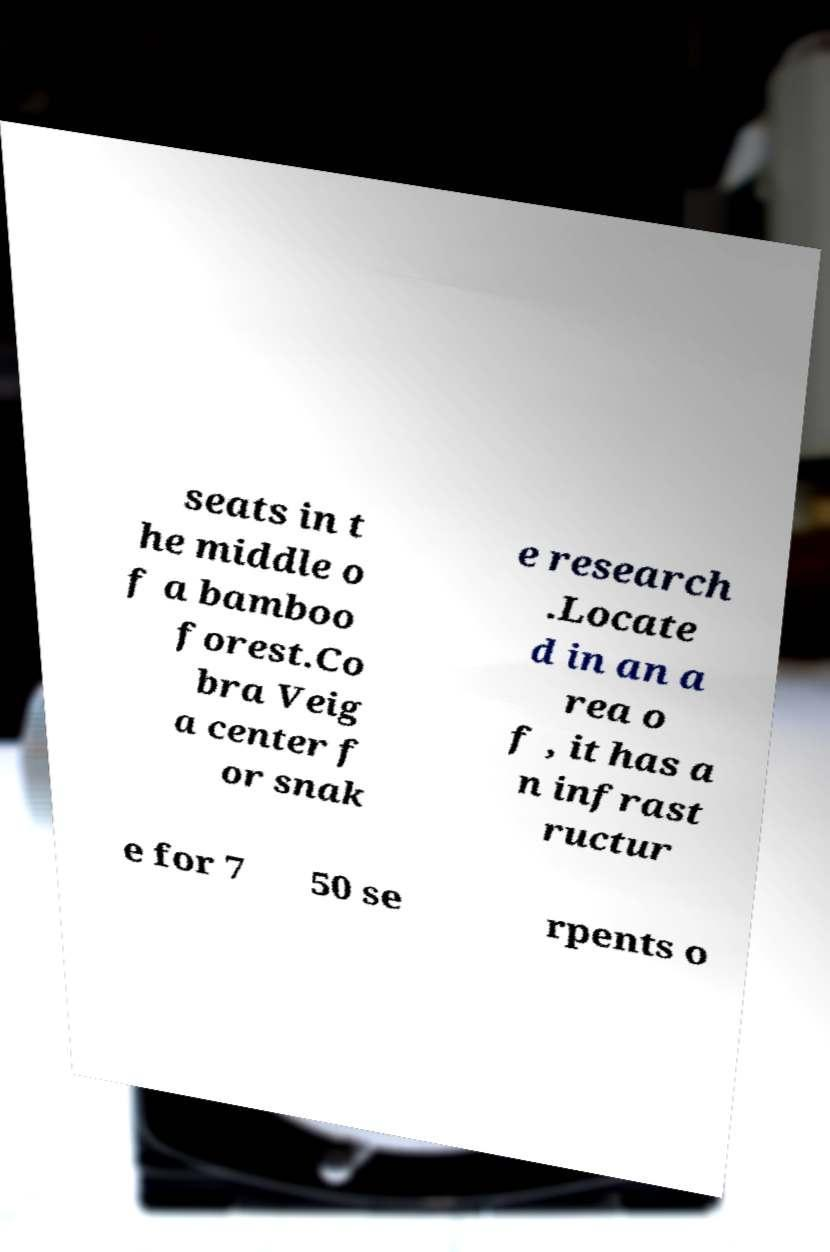What messages or text are displayed in this image? I need them in a readable, typed format. seats in t he middle o f a bamboo forest.Co bra Veig a center f or snak e research .Locate d in an a rea o f , it has a n infrast ructur e for 7 50 se rpents o 